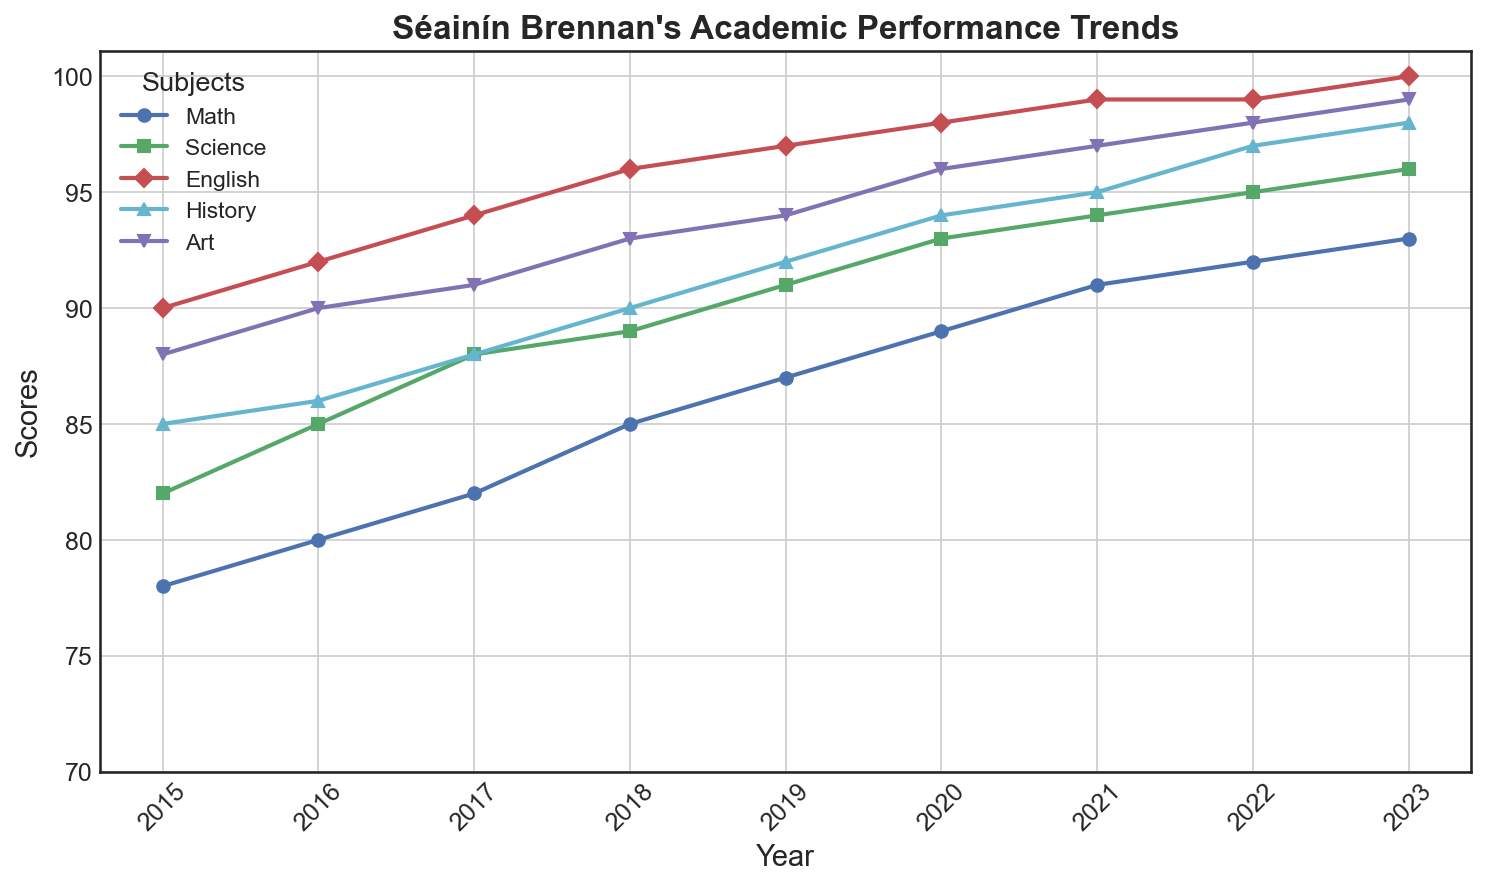What's the trend in Séainín Brennan's Math scores from 2015 to 2023? By observing the line representing Math, it starts at 78 in 2015 and steadily increases each year until it reaches 93 in 2023.
Answer: Increasing steadily Which subject showed the highest score in 2023? By looking at the endpoints of each line representing the different subjects in 2023, the English line ends at the highest point with a score of 100.
Answer: English How did Séainín's Art scores compare to History scores in 2018? From the figure, in 2018 the Art score is 93 while the History score is 90. Comparing these, the Art score is higher.
Answer: Art is higher What is the average score of Séainín in Science from 2015 to 2023? Summing the Science scores: 82 + 85 + 88 + 89 + 91 + 93 + 94 + 95 + 96 = 813. Dividing by the number of years (9) gives 813 / 9 ≈ 90.33.
Answer: 90.33 Which subject had the steepest improvement between 2015 and 2023? By comparing the slopes of the lines from 2015 to 2023, the English line shows the largest increase from 90 to 100, an increase of 10 points.
Answer: English What was the difference between the highest and lowest subject scores in 2017? The scores in 2017 are: Math (82), Science (88), English (94), History (88), Art (91). The highest is English with 94, and the lowest is Math with 82. The difference is 94 - 82 = 12.
Answer: 12 What is the median value of Séainín’s Math scores over the years? Ordering the Math scores: 78, 80, 82, 85, 87, 89, 91, 92, 93. The median value is the middle score, which is 87.
Answer: 87 In which year did Séainín's English score first reach 99? By following the English line, it first touches 99 in the year 2021.
Answer: 2021 How many years did the History scores stay above 90? By examining the History line, we see the scores above 90 in 2019, 2020, 2021, 2022, and 2023, making it 5 years.
Answer: 5 years 